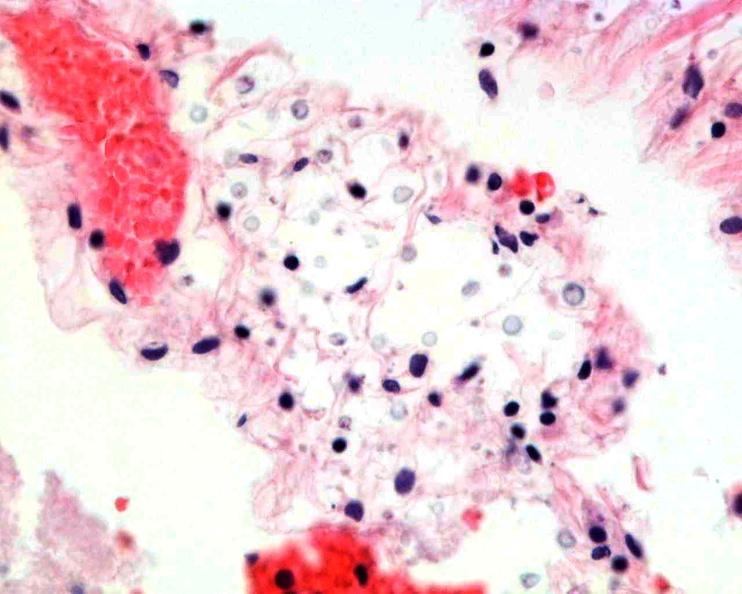does this image show brain, cryptococcal meningitis?
Answer the question using a single word or phrase. Yes 